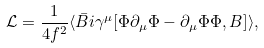Convert formula to latex. <formula><loc_0><loc_0><loc_500><loc_500>\mathcal { L } = \frac { 1 } { 4 f ^ { 2 } } \langle \bar { B } i \gamma ^ { \mu } [ \Phi \partial _ { \mu } \Phi - \partial _ { \mu } \Phi \Phi , B ] \rangle ,</formula> 